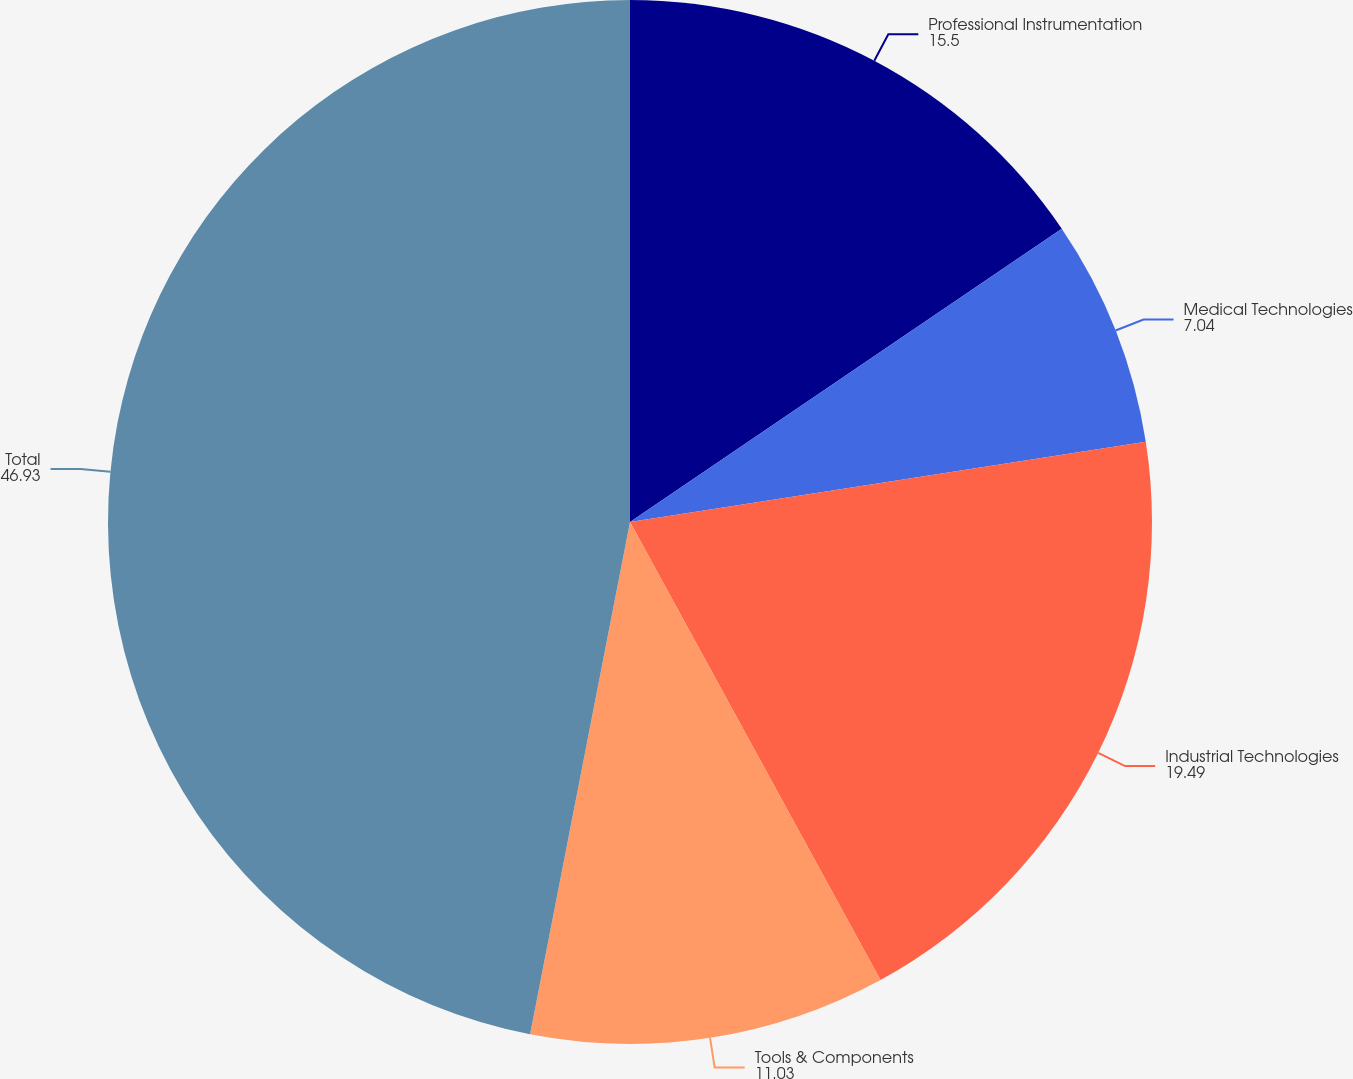<chart> <loc_0><loc_0><loc_500><loc_500><pie_chart><fcel>Professional Instrumentation<fcel>Medical Technologies<fcel>Industrial Technologies<fcel>Tools & Components<fcel>Total<nl><fcel>15.5%<fcel>7.04%<fcel>19.49%<fcel>11.03%<fcel>46.93%<nl></chart> 